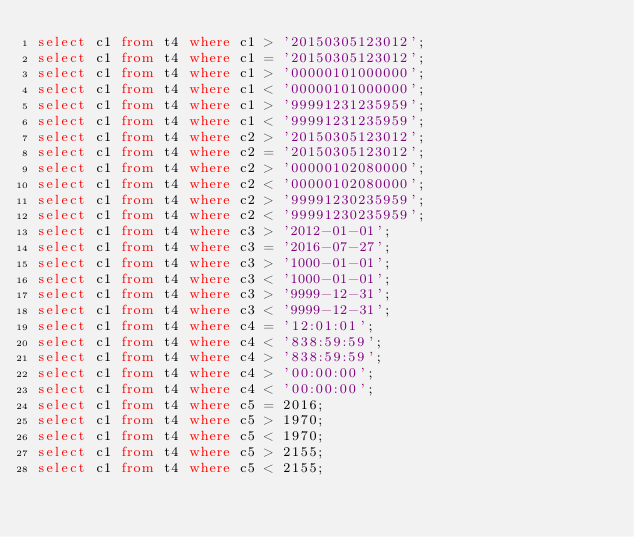Convert code to text. <code><loc_0><loc_0><loc_500><loc_500><_SQL_>select c1 from t4 where c1 > '20150305123012';
select c1 from t4 where c1 = '20150305123012';
select c1 from t4 where c1 > '00000101000000';
select c1 from t4 where c1 < '00000101000000';
select c1 from t4 where c1 > '99991231235959';
select c1 from t4 where c1 < '99991231235959';
select c1 from t4 where c2 > '20150305123012';
select c1 from t4 where c2 = '20150305123012';
select c1 from t4 where c2 > '00000102080000';
select c1 from t4 where c2 < '00000102080000';
select c1 from t4 where c2 > '99991230235959';
select c1 from t4 where c2 < '99991230235959';
select c1 from t4 where c3 > '2012-01-01';
select c1 from t4 where c3 = '2016-07-27';
select c1 from t4 where c3 > '1000-01-01';
select c1 from t4 where c3 < '1000-01-01';
select c1 from t4 where c3 > '9999-12-31';
select c1 from t4 where c3 < '9999-12-31';
select c1 from t4 where c4 = '12:01:01';
select c1 from t4 where c4 < '838:59:59';
select c1 from t4 where c4 > '838:59:59';
select c1 from t4 where c4 > '00:00:00';
select c1 from t4 where c4 < '00:00:00';
select c1 from t4 where c5 = 2016;
select c1 from t4 where c5 > 1970;
select c1 from t4 where c5 < 1970;
select c1 from t4 where c5 > 2155;
select c1 from t4 where c5 < 2155;
</code> 